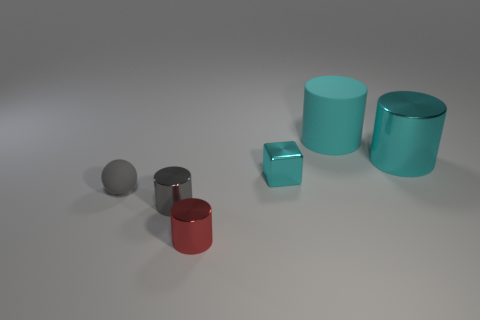Subtract all small red shiny cylinders. How many cylinders are left? 3 Subtract all red cylinders. How many cylinders are left? 3 Subtract all yellow balls. How many cyan cylinders are left? 2 Add 3 blue objects. How many objects exist? 9 Subtract 3 cylinders. How many cylinders are left? 1 Subtract all blocks. How many objects are left? 5 Subtract all large blue rubber blocks. Subtract all tiny red shiny things. How many objects are left? 5 Add 4 small red things. How many small red things are left? 5 Add 5 small gray matte spheres. How many small gray matte spheres exist? 6 Subtract 0 cyan balls. How many objects are left? 6 